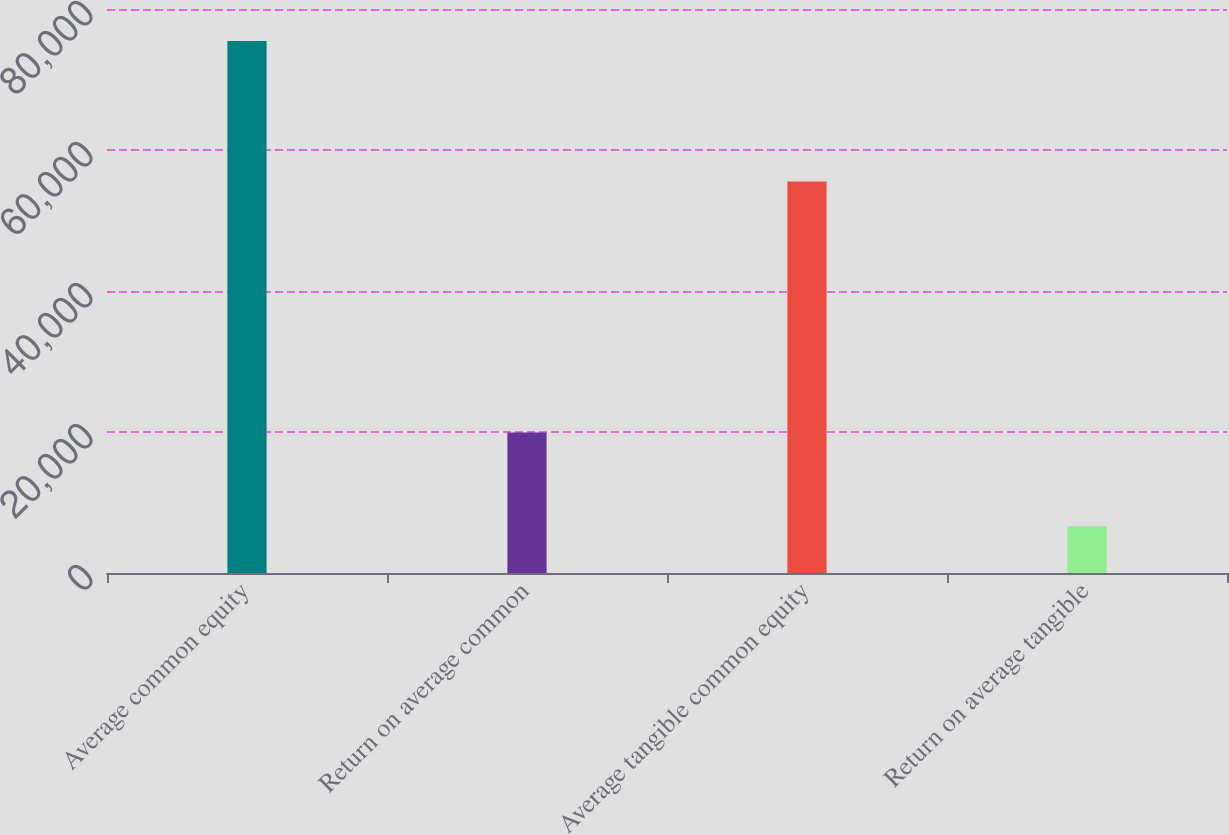Convert chart to OTSL. <chart><loc_0><loc_0><loc_500><loc_500><bar_chart><fcel>Average common equity<fcel>Return on average common<fcel>Average tangible common equity<fcel>Return on average tangible<nl><fcel>75465.4<fcel>19918.2<fcel>55548<fcel>6639.92<nl></chart> 